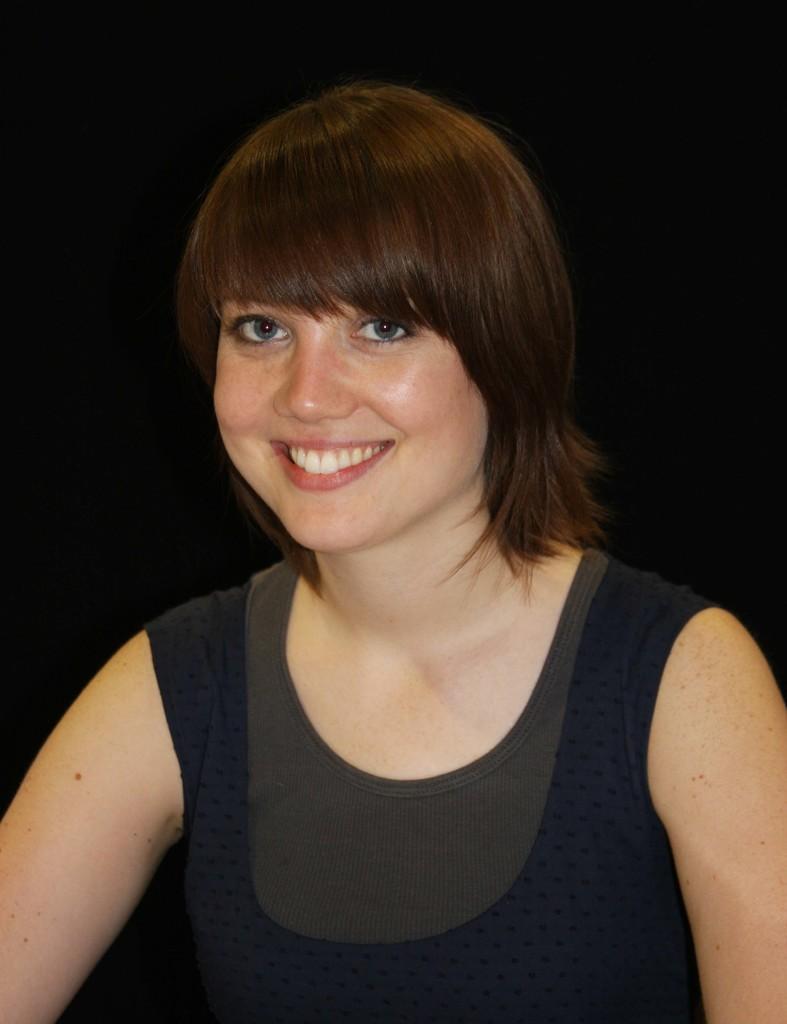Describe this image in one or two sentences. In this image we can see a woman smiling and the background is dark. 